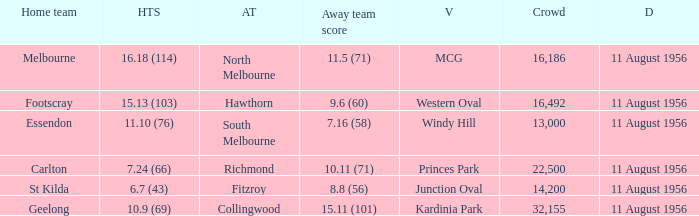What home team played at western oval? Footscray. 